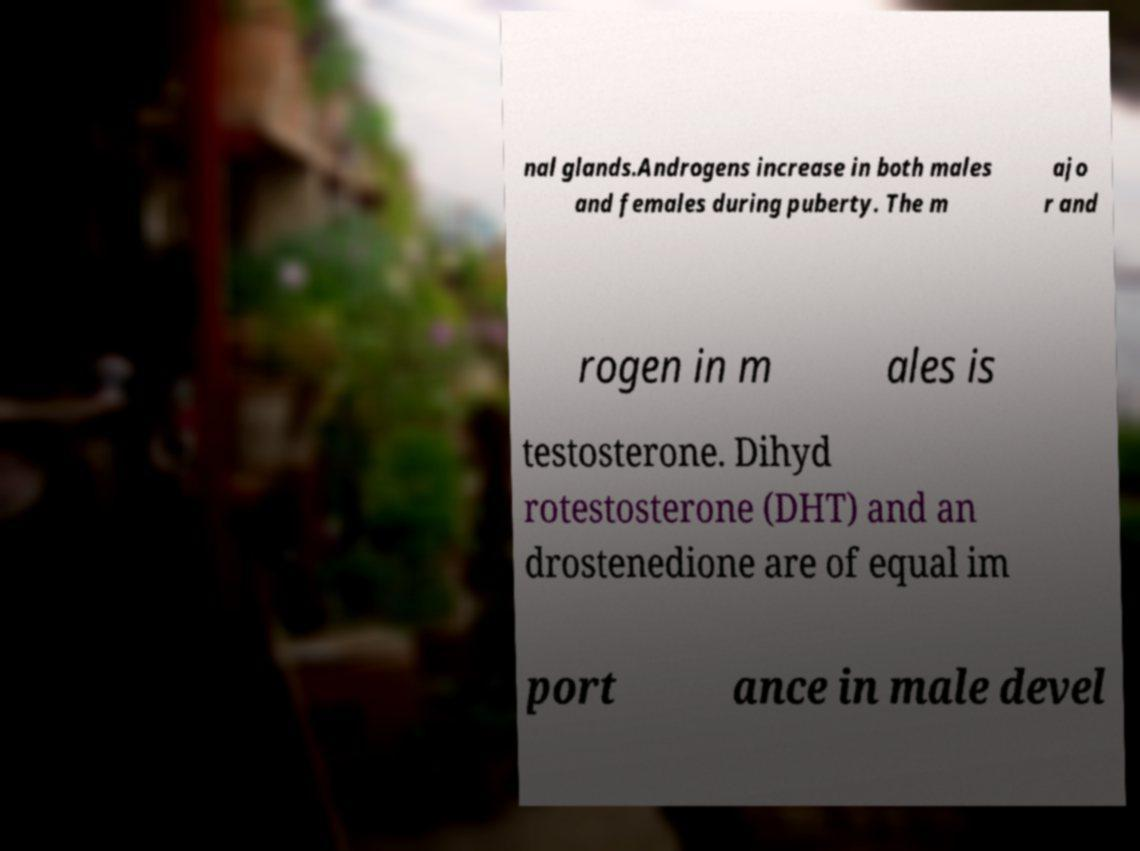Can you accurately transcribe the text from the provided image for me? nal glands.Androgens increase in both males and females during puberty. The m ajo r and rogen in m ales is testosterone. Dihyd rotestosterone (DHT) and an drostenedione are of equal im port ance in male devel 